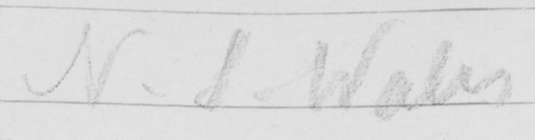What does this handwritten line say? N.S . Wales 